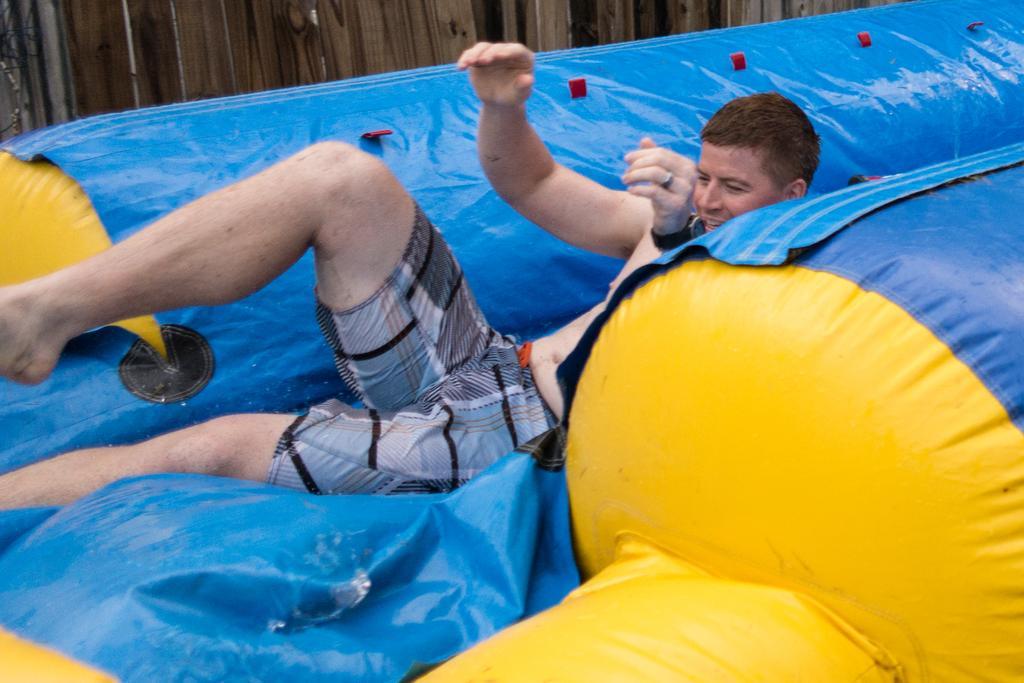Could you give a brief overview of what you see in this image? In this image there is a man on the object which is yellow and blue in colour. In the background there is a wooden fence. 